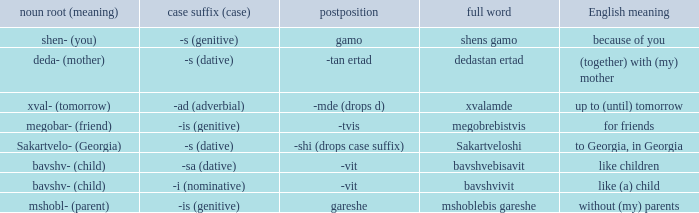What is Postposition, when Noun Root (Meaning) is "mshobl- (parent)"? Gareshe. 